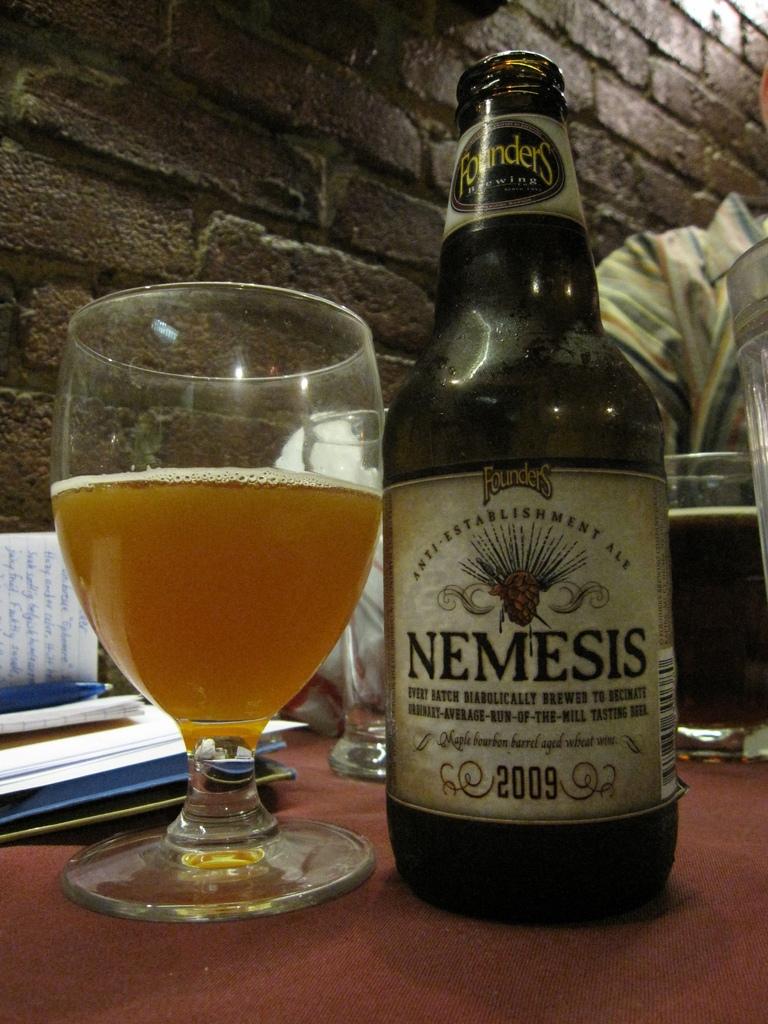Is this the name of a beer?
Offer a terse response. Nemesis. What year is the wine?
Offer a terse response. 2009. 